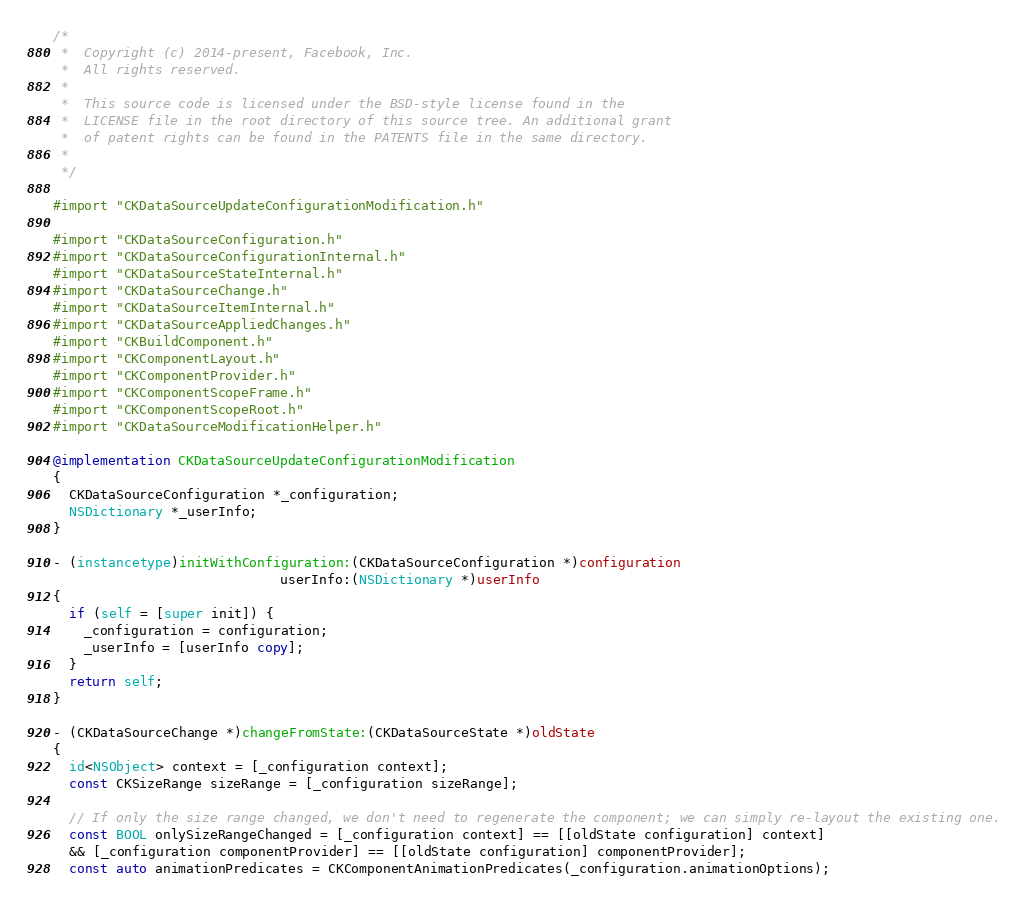Convert code to text. <code><loc_0><loc_0><loc_500><loc_500><_ObjectiveC_>/*
 *  Copyright (c) 2014-present, Facebook, Inc.
 *  All rights reserved.
 *
 *  This source code is licensed under the BSD-style license found in the
 *  LICENSE file in the root directory of this source tree. An additional grant
 *  of patent rights can be found in the PATENTS file in the same directory.
 *
 */

#import "CKDataSourceUpdateConfigurationModification.h"

#import "CKDataSourceConfiguration.h"
#import "CKDataSourceConfigurationInternal.h"
#import "CKDataSourceStateInternal.h"
#import "CKDataSourceChange.h"
#import "CKDataSourceItemInternal.h"
#import "CKDataSourceAppliedChanges.h"
#import "CKBuildComponent.h"
#import "CKComponentLayout.h"
#import "CKComponentProvider.h"
#import "CKComponentScopeFrame.h"
#import "CKComponentScopeRoot.h"
#import "CKDataSourceModificationHelper.h"

@implementation CKDataSourceUpdateConfigurationModification
{
  CKDataSourceConfiguration *_configuration;
  NSDictionary *_userInfo;
}

- (instancetype)initWithConfiguration:(CKDataSourceConfiguration *)configuration
                             userInfo:(NSDictionary *)userInfo
{
  if (self = [super init]) {
    _configuration = configuration;
    _userInfo = [userInfo copy];
  }
  return self;
}

- (CKDataSourceChange *)changeFromState:(CKDataSourceState *)oldState
{
  id<NSObject> context = [_configuration context];
  const CKSizeRange sizeRange = [_configuration sizeRange];

  // If only the size range changed, we don't need to regenerate the component; we can simply re-layout the existing one.
  const BOOL onlySizeRangeChanged = [_configuration context] == [[oldState configuration] context]
  && [_configuration componentProvider] == [[oldState configuration] componentProvider];
  const auto animationPredicates = CKComponentAnimationPredicates(_configuration.animationOptions);
</code> 